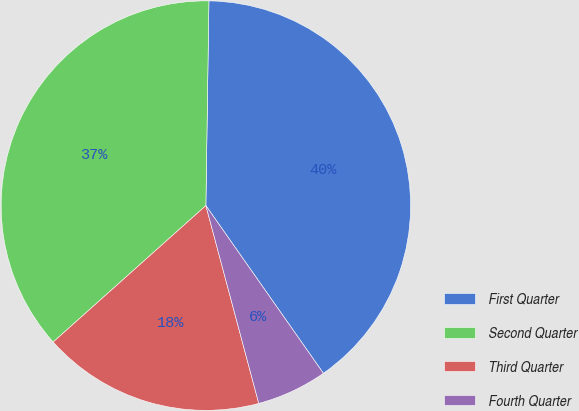Convert chart. <chart><loc_0><loc_0><loc_500><loc_500><pie_chart><fcel>First Quarter<fcel>Second Quarter<fcel>Third Quarter<fcel>Fourth Quarter<nl><fcel>40.03%<fcel>36.84%<fcel>17.55%<fcel>5.57%<nl></chart> 